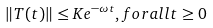<formula> <loc_0><loc_0><loc_500><loc_500>\| T ( t ) \| \leq K e ^ { - \omega t } , f o r a l l t \geq 0</formula> 